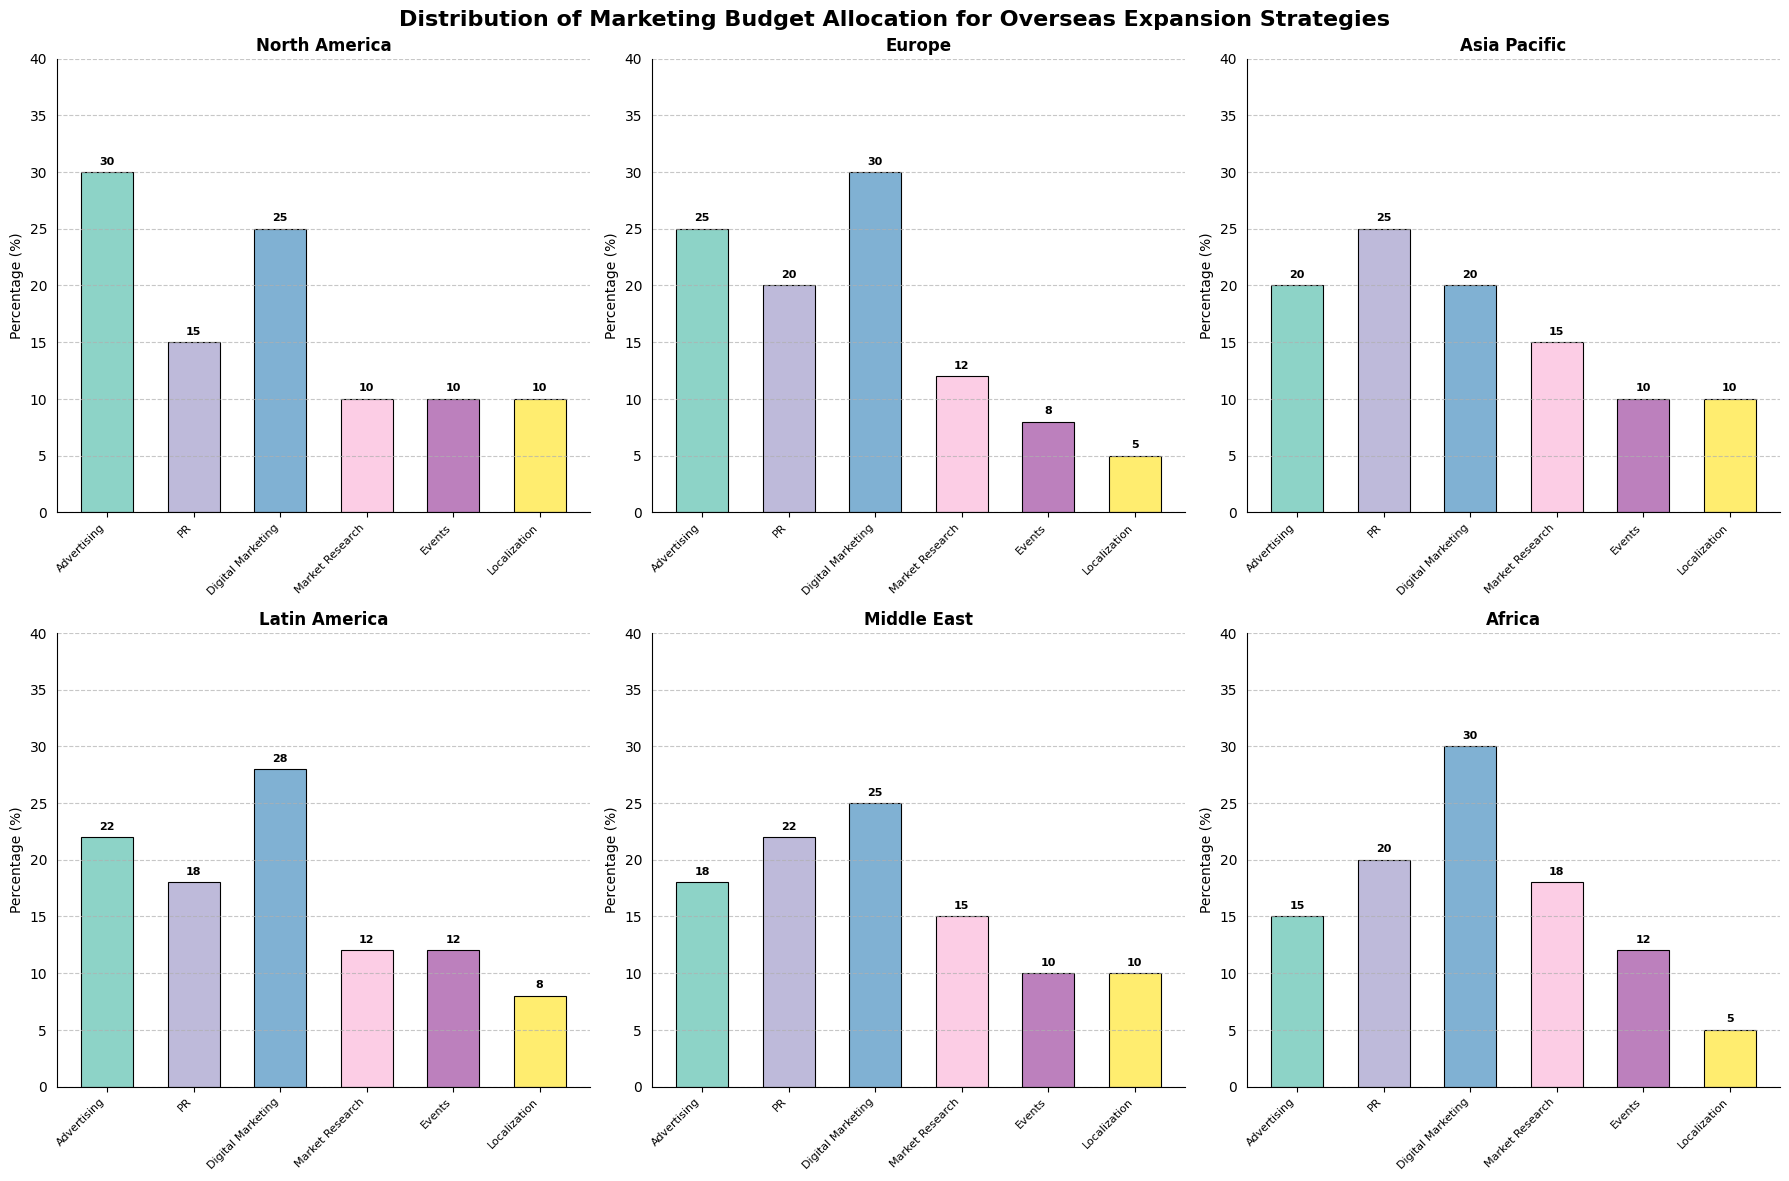What is the title of the figure? The title of the figure is written at the top in a larger and bold font.
Answer: Distribution of Marketing Budget Allocation for Overseas Expansion Strategies Which region allocates the highest percentage to Market Research? Look at the Market Research bars and find the one with the highest percentage.
Answer: Africa (18%) How much budget percentage does North America allocate to Advertising and Localization combined? Find North America's values for Advertising and Localization and sum them up: 30 (Advertising) + 10 (Localization).
Answer: 40% Which strategy region has the lowest allocation for Events? Identify which region has the smallest bar for Events by comparing the heights of the Events bars.
Answer: Europe (8%) Compare the budget allocation for Digital Marketing in Europe and Asia Pacific. Which of these spends more? Look at the Digital Marketing bars for Europe and Asia Pacific, and compare their heights.
Answer: Europe (30%) Is the allocation for PR consistent across all regions? Check the PR bars for all regions to see if they are the same height or vary.
Answer: No What is the average budget percentage allocated to Digital Marketing across all regions? Sum the Digital Marketing percentages for all regions and divide by the number of regions: (25 + 30 + 20 + 28 + 25 + 30) / 6.
Answer: 26.33% Calculate the difference in Events budget allocation between Latin America and North America. Subtract North America's Events percentage from Latin America's Events percentage: 12 (Latin America) - 10 (North America).
Answer: 2% Which category does the Middle East allocate the highest percentage to? Look at the Middle East's bars and find the highest one.
Answer: PR (22%) What is the total budget percentage allocated to Advertising and Digital Marketing in Asia Pacific? Sum Asia Pacific's values for Advertising and Digital Marketing: 20 (Advertising) + 20 (Digital Marketing).
Answer: 40% 